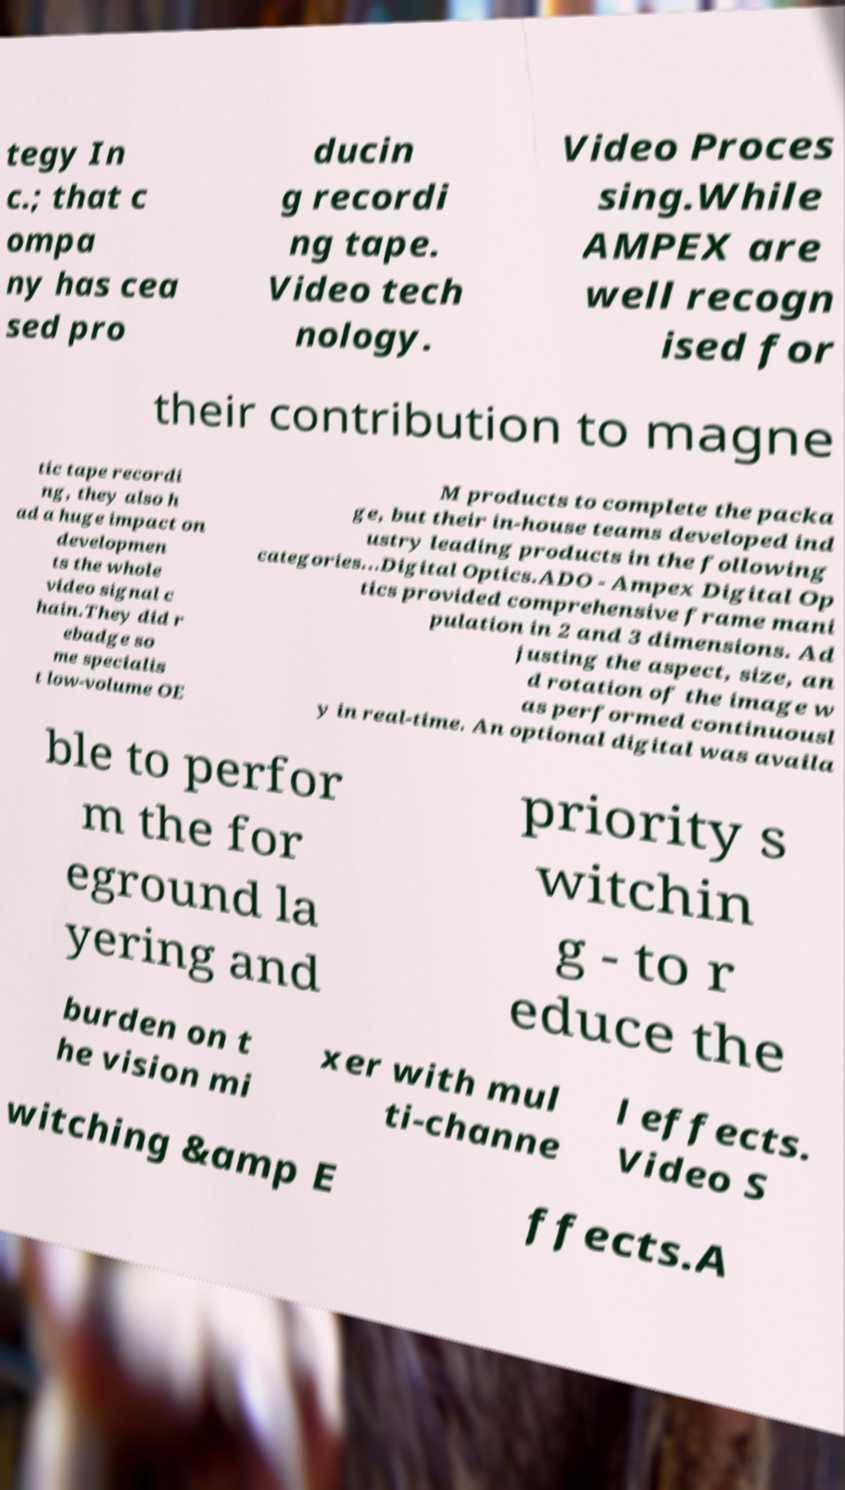What messages or text are displayed in this image? I need them in a readable, typed format. tegy In c.; that c ompa ny has cea sed pro ducin g recordi ng tape. Video tech nology. Video Proces sing.While AMPEX are well recogn ised for their contribution to magne tic tape recordi ng, they also h ad a huge impact on developmen ts the whole video signal c hain.They did r ebadge so me specialis t low-volume OE M products to complete the packa ge, but their in-house teams developed ind ustry leading products in the following categories...Digital Optics.ADO - Ampex Digital Op tics provided comprehensive frame mani pulation in 2 and 3 dimensions. Ad justing the aspect, size, an d rotation of the image w as performed continuousl y in real-time. An optional digital was availa ble to perfor m the for eground la yering and priority s witchin g - to r educe the burden on t he vision mi xer with mul ti-channe l effects. Video S witching &amp E ffects.A 